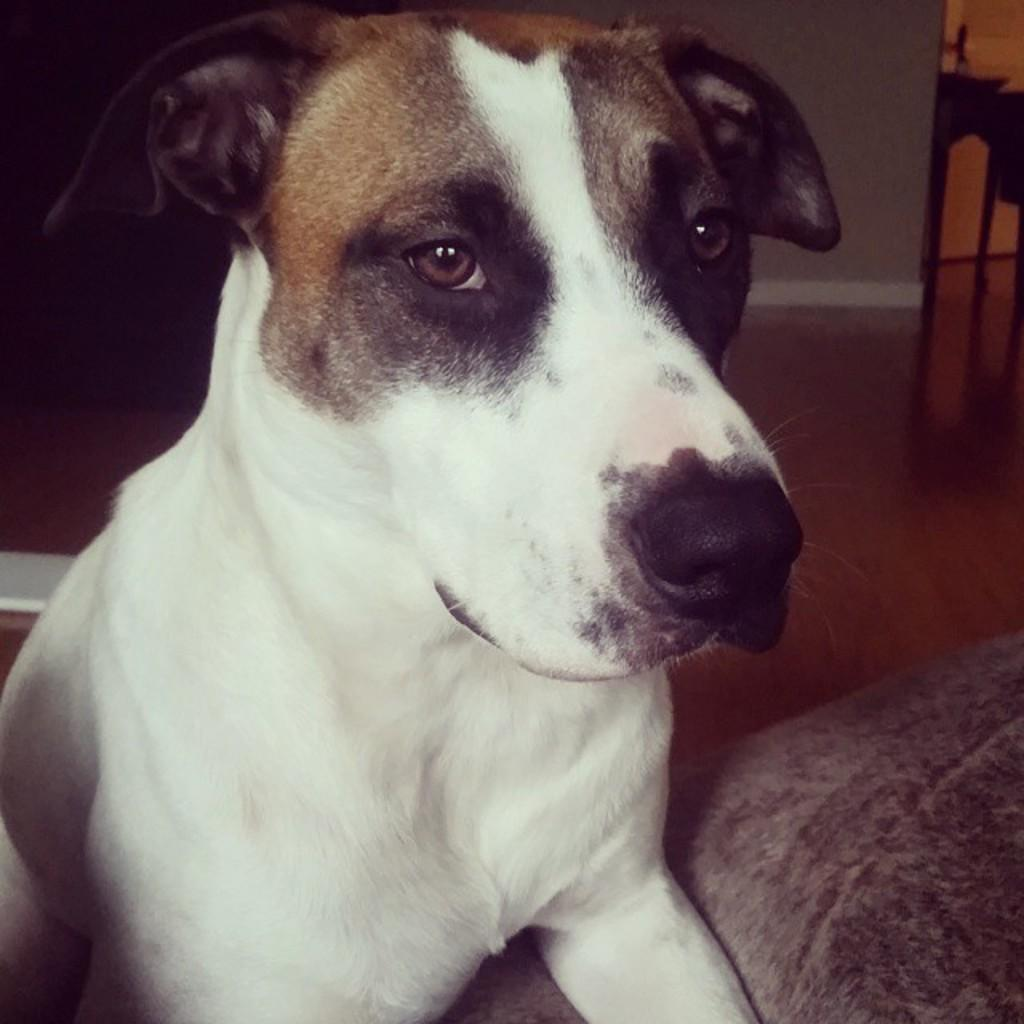What animal can be seen in the image? There is a dog in the image. Where is the dog located? The dog is on a sofa. What can be seen in the background of the image? There is a wall in the background of the image. What type of milk is the dog drinking from the plate in the image? There is no milk or plate present in the image; it only features a dog on a sofa with a wall in the background. 